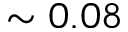<formula> <loc_0><loc_0><loc_500><loc_500>\sim 0 . 0 8</formula> 